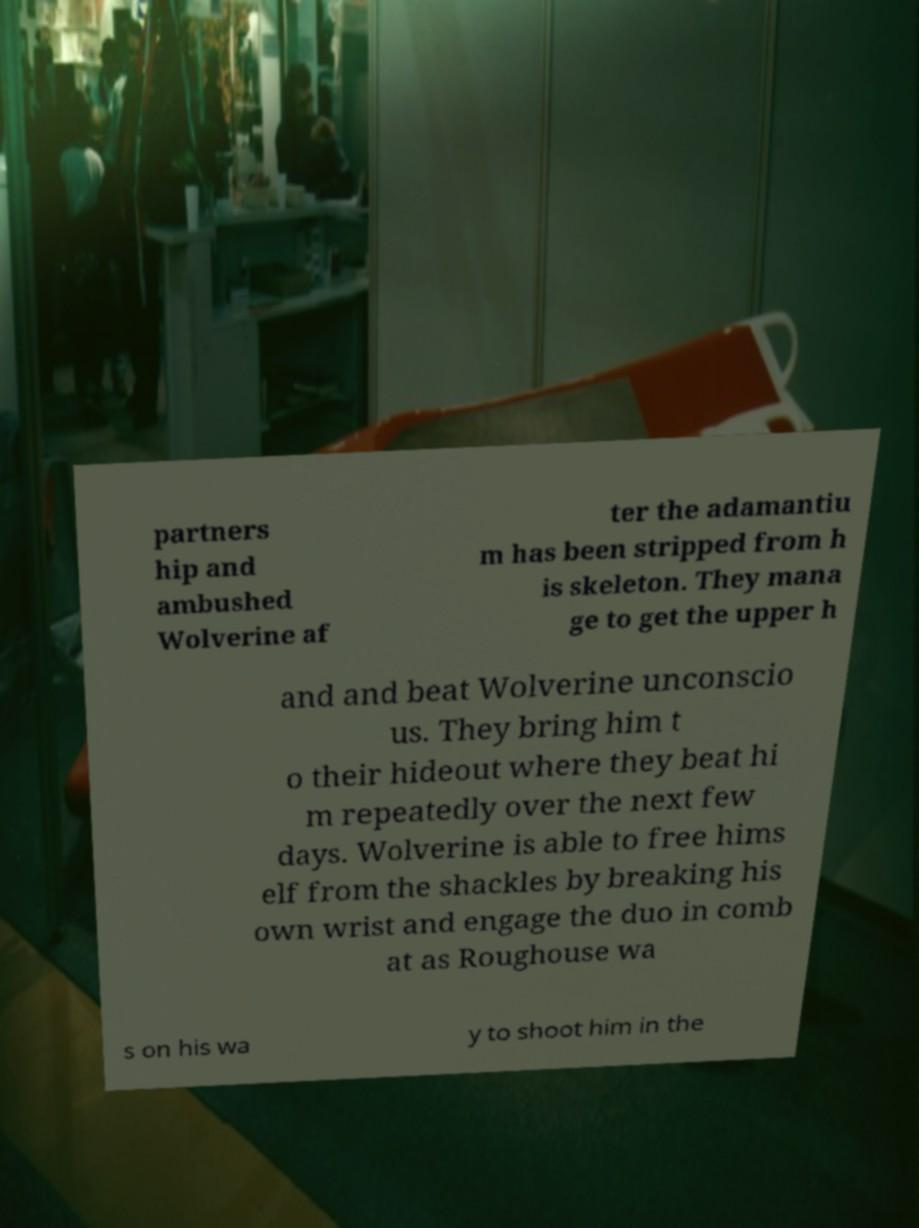For documentation purposes, I need the text within this image transcribed. Could you provide that? partners hip and ambushed Wolverine af ter the adamantiu m has been stripped from h is skeleton. They mana ge to get the upper h and and beat Wolverine unconscio us. They bring him t o their hideout where they beat hi m repeatedly over the next few days. Wolverine is able to free hims elf from the shackles by breaking his own wrist and engage the duo in comb at as Roughouse wa s on his wa y to shoot him in the 